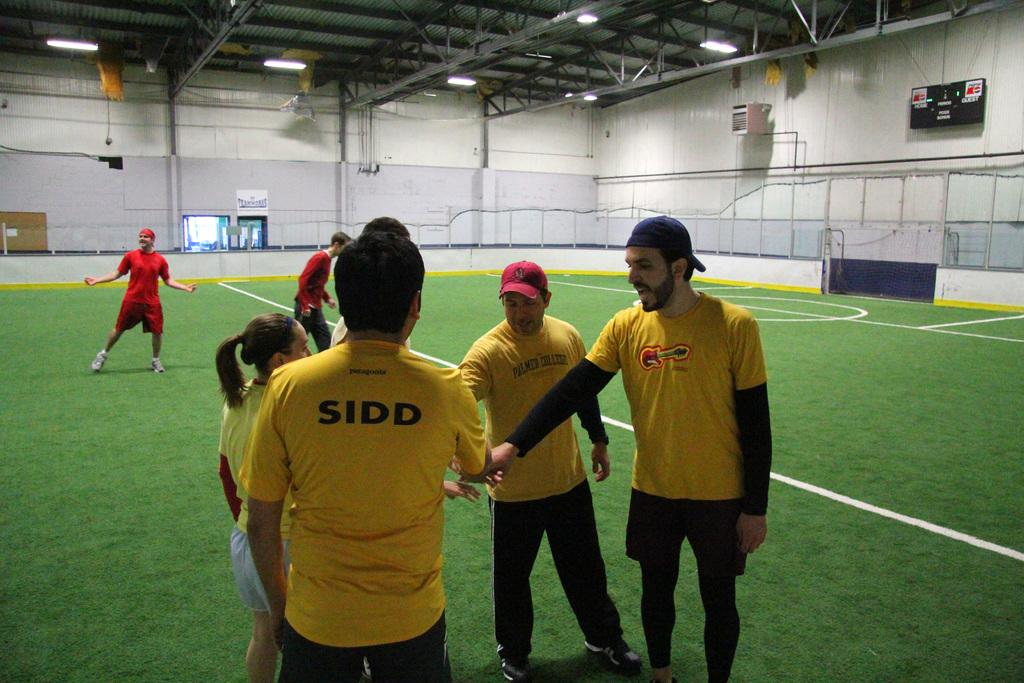<image>
Render a clear and concise summary of the photo. Four people in yellow tops put their hands together in a gym, the back of one top reads SIDD. 